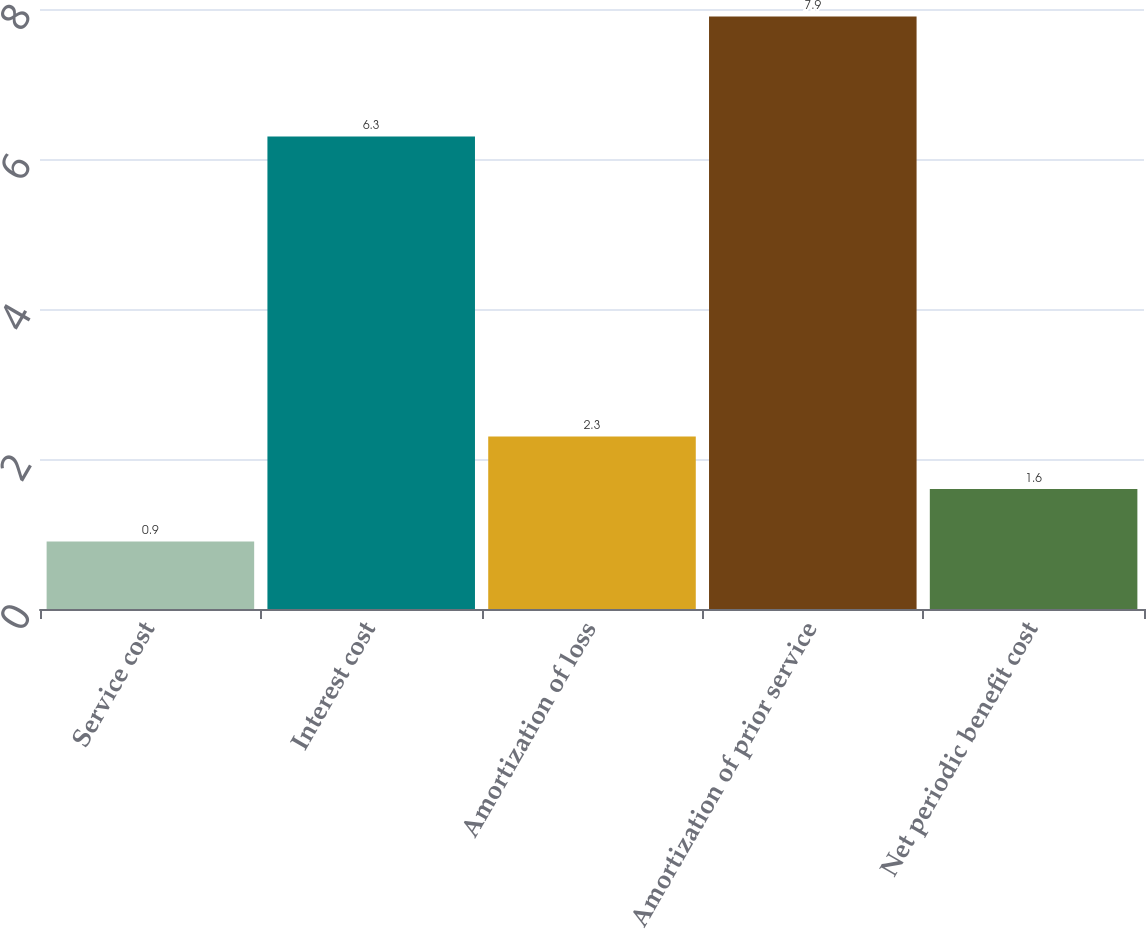Convert chart. <chart><loc_0><loc_0><loc_500><loc_500><bar_chart><fcel>Service cost<fcel>Interest cost<fcel>Amortization of loss<fcel>Amortization of prior service<fcel>Net periodic benefit cost<nl><fcel>0.9<fcel>6.3<fcel>2.3<fcel>7.9<fcel>1.6<nl></chart> 